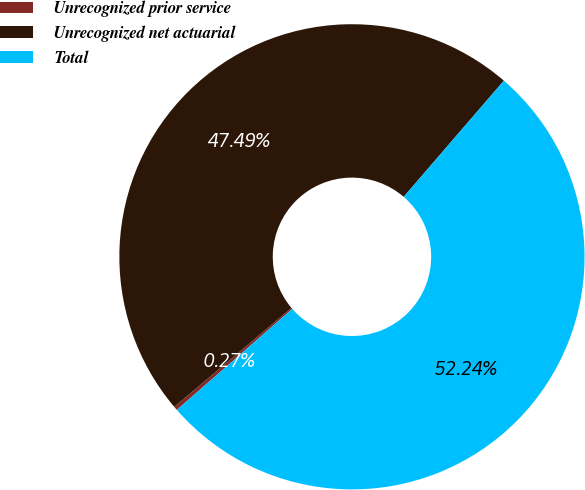<chart> <loc_0><loc_0><loc_500><loc_500><pie_chart><fcel>Unrecognized prior service<fcel>Unrecognized net actuarial<fcel>Total<nl><fcel>0.27%<fcel>47.49%<fcel>52.24%<nl></chart> 